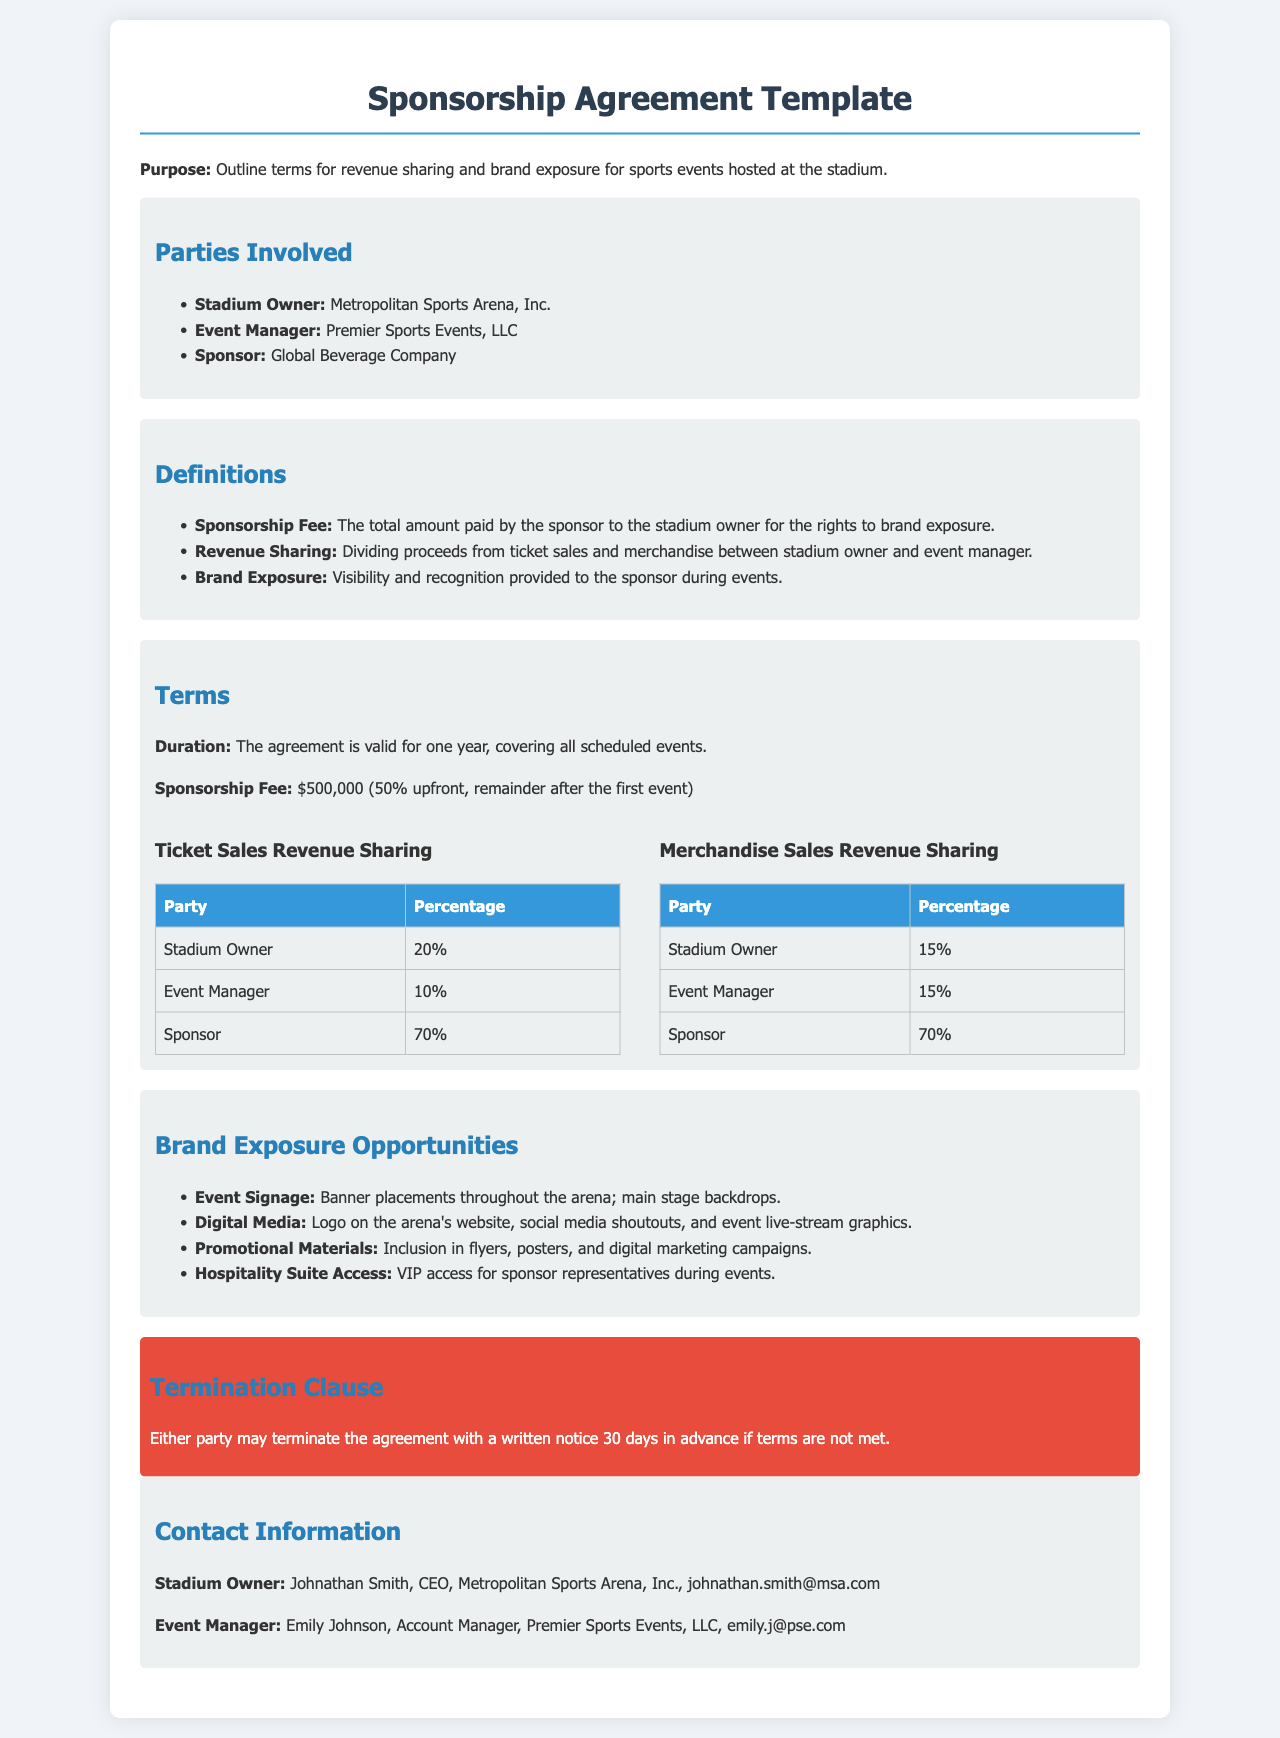What is the purpose of the agreement? The purpose defines the main objective of the document, which is to outline terms for revenue sharing and brand exposure for sports events hosted at the stadium.
Answer: Outline terms for revenue sharing and brand exposure for sports events hosted at the stadium Who is the stadium owner? This question asks for the name of the organization that owns the stadium, as specified in the document.
Answer: Metropolitan Sports Arena, Inc What is the sponsorship fee? This value represents the total amount agreed upon for the sponsorship rights as stated in the terms section.
Answer: $500,000 What percentage of ticket sales does the stadium owner receive? This question involves finding the specific percentage allocated to the stadium owner in the ticket sales revenue-sharing model.
Answer: 20% What opportunities are included under brand exposure? This question requires identifying the various avenues for brand visibility mentioned in the document.
Answer: Event Signage, Digital Media, Promotional Materials, Hospitality Suite Access How many days advance notice is required for termination? This question seeks the specified notice period needed for either party to terminate the agreement as indicated in the termination clause.
Answer: 30 days What percentage does the sponsor receive from merchandise sales? The question focuses on the share that the sponsor will receive from the merchandise sales revenue model.
Answer: 70% Who is the contact person for the event manager? This asks for the specific name of the individual responsible for managing events on behalf of the event manager.
Answer: Emily Johnson What is the duration of the agreement? This question focuses on the length of time for which the agreement is valid as stated in the terms section.
Answer: One year 